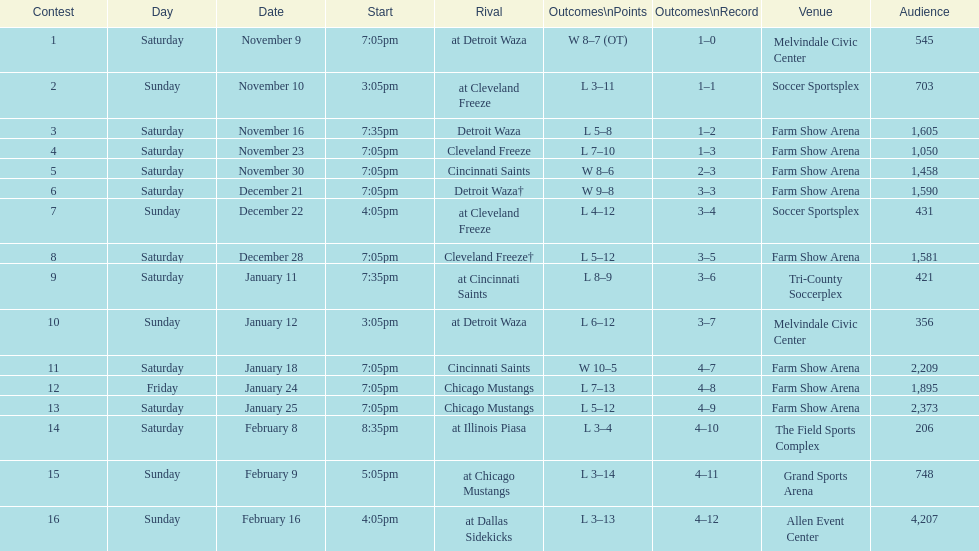Parse the full table. {'header': ['Contest', 'Day', 'Date', 'Start', 'Rival', 'Outcomes\\nPoints', 'Outcomes\\nRecord', 'Venue', 'Audience'], 'rows': [['1', 'Saturday', 'November 9', '7:05pm', 'at Detroit Waza', 'W 8–7 (OT)', '1–0', 'Melvindale Civic Center', '545'], ['2', 'Sunday', 'November 10', '3:05pm', 'at Cleveland Freeze', 'L 3–11', '1–1', 'Soccer Sportsplex', '703'], ['3', 'Saturday', 'November 16', '7:35pm', 'Detroit Waza', 'L 5–8', '1–2', 'Farm Show Arena', '1,605'], ['4', 'Saturday', 'November 23', '7:05pm', 'Cleveland Freeze', 'L 7–10', '1–3', 'Farm Show Arena', '1,050'], ['5', 'Saturday', 'November 30', '7:05pm', 'Cincinnati Saints', 'W 8–6', '2–3', 'Farm Show Arena', '1,458'], ['6', 'Saturday', 'December 21', '7:05pm', 'Detroit Waza†', 'W 9–8', '3–3', 'Farm Show Arena', '1,590'], ['7', 'Sunday', 'December 22', '4:05pm', 'at Cleveland Freeze', 'L 4–12', '3–4', 'Soccer Sportsplex', '431'], ['8', 'Saturday', 'December 28', '7:05pm', 'Cleveland Freeze†', 'L 5–12', '3–5', 'Farm Show Arena', '1,581'], ['9', 'Saturday', 'January 11', '7:35pm', 'at Cincinnati Saints', 'L 8–9', '3–6', 'Tri-County Soccerplex', '421'], ['10', 'Sunday', 'January 12', '3:05pm', 'at Detroit Waza', 'L 6–12', '3–7', 'Melvindale Civic Center', '356'], ['11', 'Saturday', 'January 18', '7:05pm', 'Cincinnati Saints', 'W 10–5', '4–7', 'Farm Show Arena', '2,209'], ['12', 'Friday', 'January 24', '7:05pm', 'Chicago Mustangs', 'L 7–13', '4–8', 'Farm Show Arena', '1,895'], ['13', 'Saturday', 'January 25', '7:05pm', 'Chicago Mustangs', 'L 5–12', '4–9', 'Farm Show Arena', '2,373'], ['14', 'Saturday', 'February 8', '8:35pm', 'at Illinois Piasa', 'L 3–4', '4–10', 'The Field Sports Complex', '206'], ['15', 'Sunday', 'February 9', '5:05pm', 'at Chicago Mustangs', 'L 3–14', '4–11', 'Grand Sports Arena', '748'], ['16', 'Sunday', 'February 16', '4:05pm', 'at Dallas Sidekicks', 'L 3–13', '4–12', 'Allen Event Center', '4,207']]} Who was the first opponent on this list? Detroit Waza. 